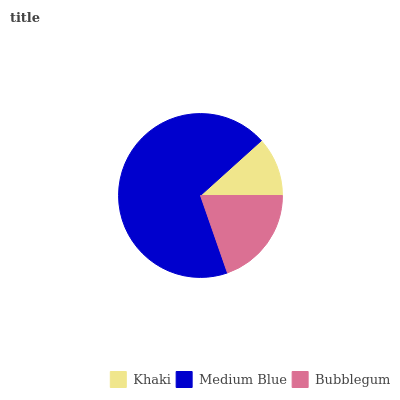Is Khaki the minimum?
Answer yes or no. Yes. Is Medium Blue the maximum?
Answer yes or no. Yes. Is Bubblegum the minimum?
Answer yes or no. No. Is Bubblegum the maximum?
Answer yes or no. No. Is Medium Blue greater than Bubblegum?
Answer yes or no. Yes. Is Bubblegum less than Medium Blue?
Answer yes or no. Yes. Is Bubblegum greater than Medium Blue?
Answer yes or no. No. Is Medium Blue less than Bubblegum?
Answer yes or no. No. Is Bubblegum the high median?
Answer yes or no. Yes. Is Bubblegum the low median?
Answer yes or no. Yes. Is Khaki the high median?
Answer yes or no. No. Is Medium Blue the low median?
Answer yes or no. No. 